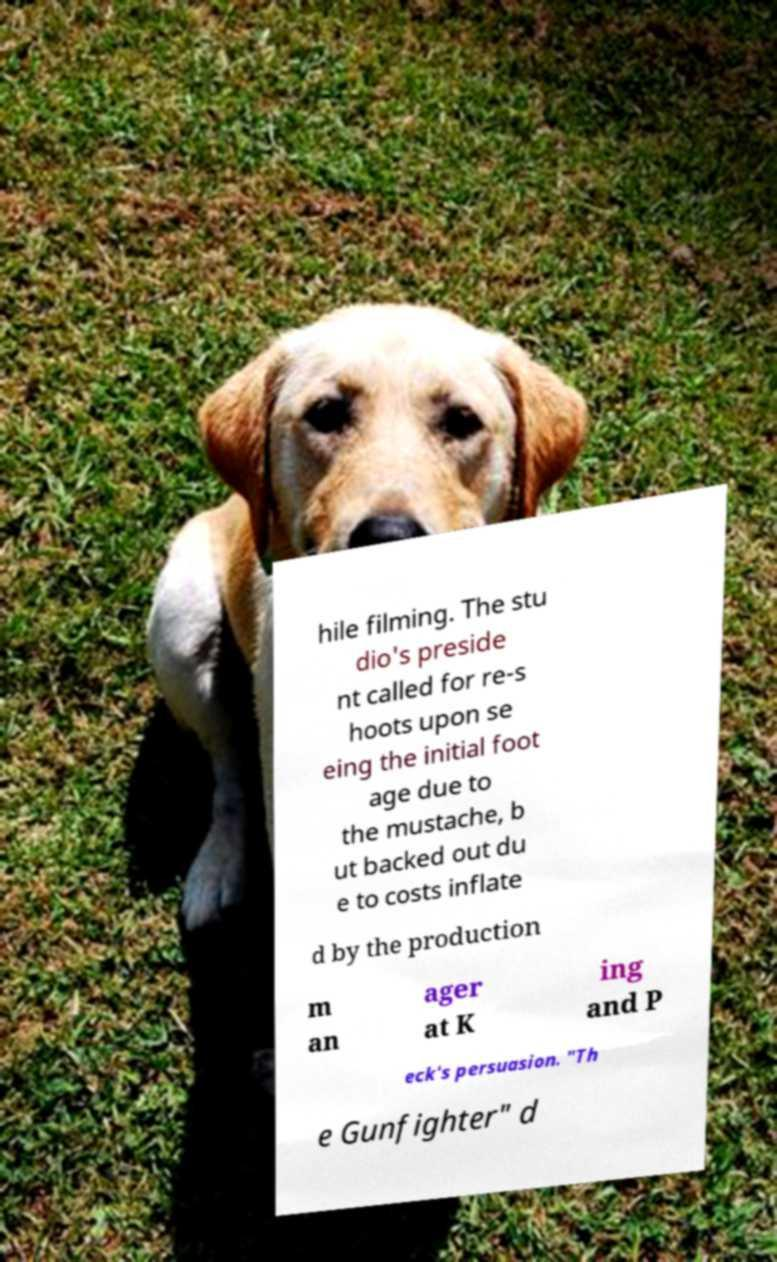Could you extract and type out the text from this image? hile filming. The stu dio's preside nt called for re-s hoots upon se eing the initial foot age due to the mustache, b ut backed out du e to costs inflate d by the production m an ager at K ing and P eck's persuasion. "Th e Gunfighter" d 